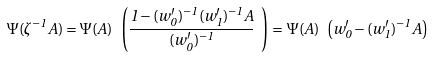Convert formula to latex. <formula><loc_0><loc_0><loc_500><loc_500>\Psi ( \zeta ^ { - 1 } A ) = \Psi ( A ) \ \left ( \frac { 1 - ( w _ { 0 } ^ { \prime } ) ^ { - 1 } ( w _ { 1 } ^ { \prime } ) ^ { - 1 } A } { ( w _ { 0 } ^ { \prime } ) ^ { - 1 } } \ \right ) = \Psi ( A ) \ \left ( w _ { 0 } ^ { \prime } - ( w _ { 1 } ^ { \prime } ) ^ { - 1 } A \right )</formula> 